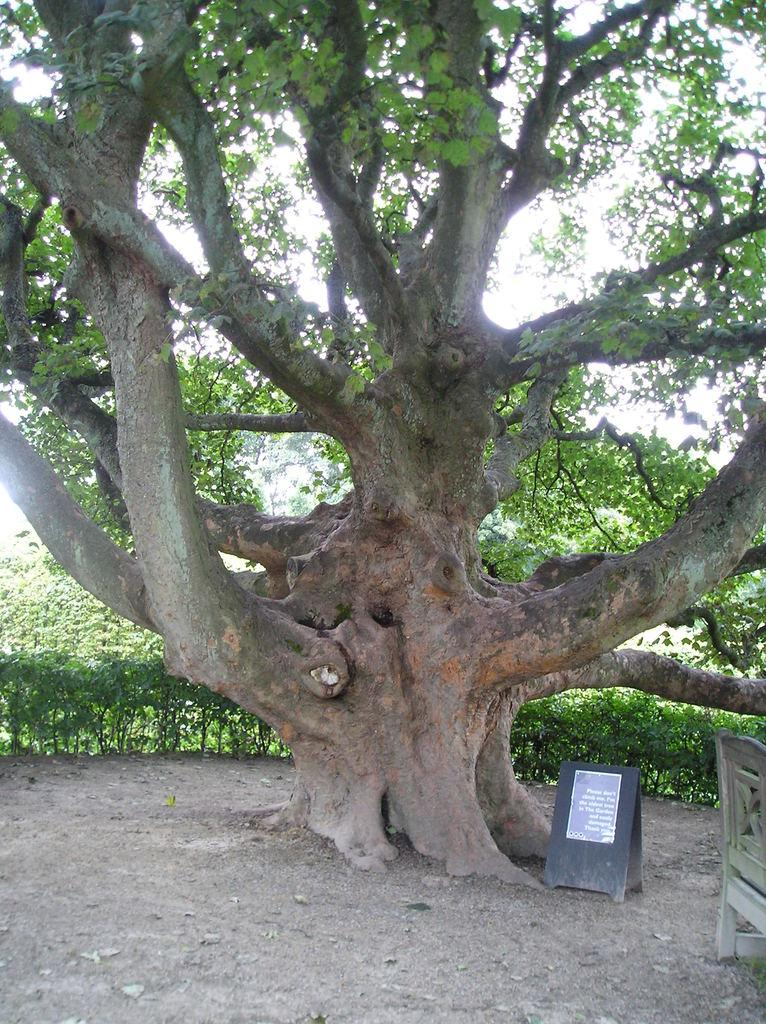What type of seating is present in the image? There is a bench in the image. What natural element can be seen in the image? There is a tree in the image. What type of vegetation is present in the image besides the tree? There are plants in the image. What is the board in the image used for? The board has a poster with text on it. What is visible in the background of the image? The sky is visible in the background of the image. Can you tell me how many roses are on the poster in the image? There is no mention of roses in the image or on the poster; it only states that the board has a poster with text on it. What type of plant is supporting the bench in the image? There is no plant supporting the bench in the image; the bench is likely placed on the ground or a flat surface. 